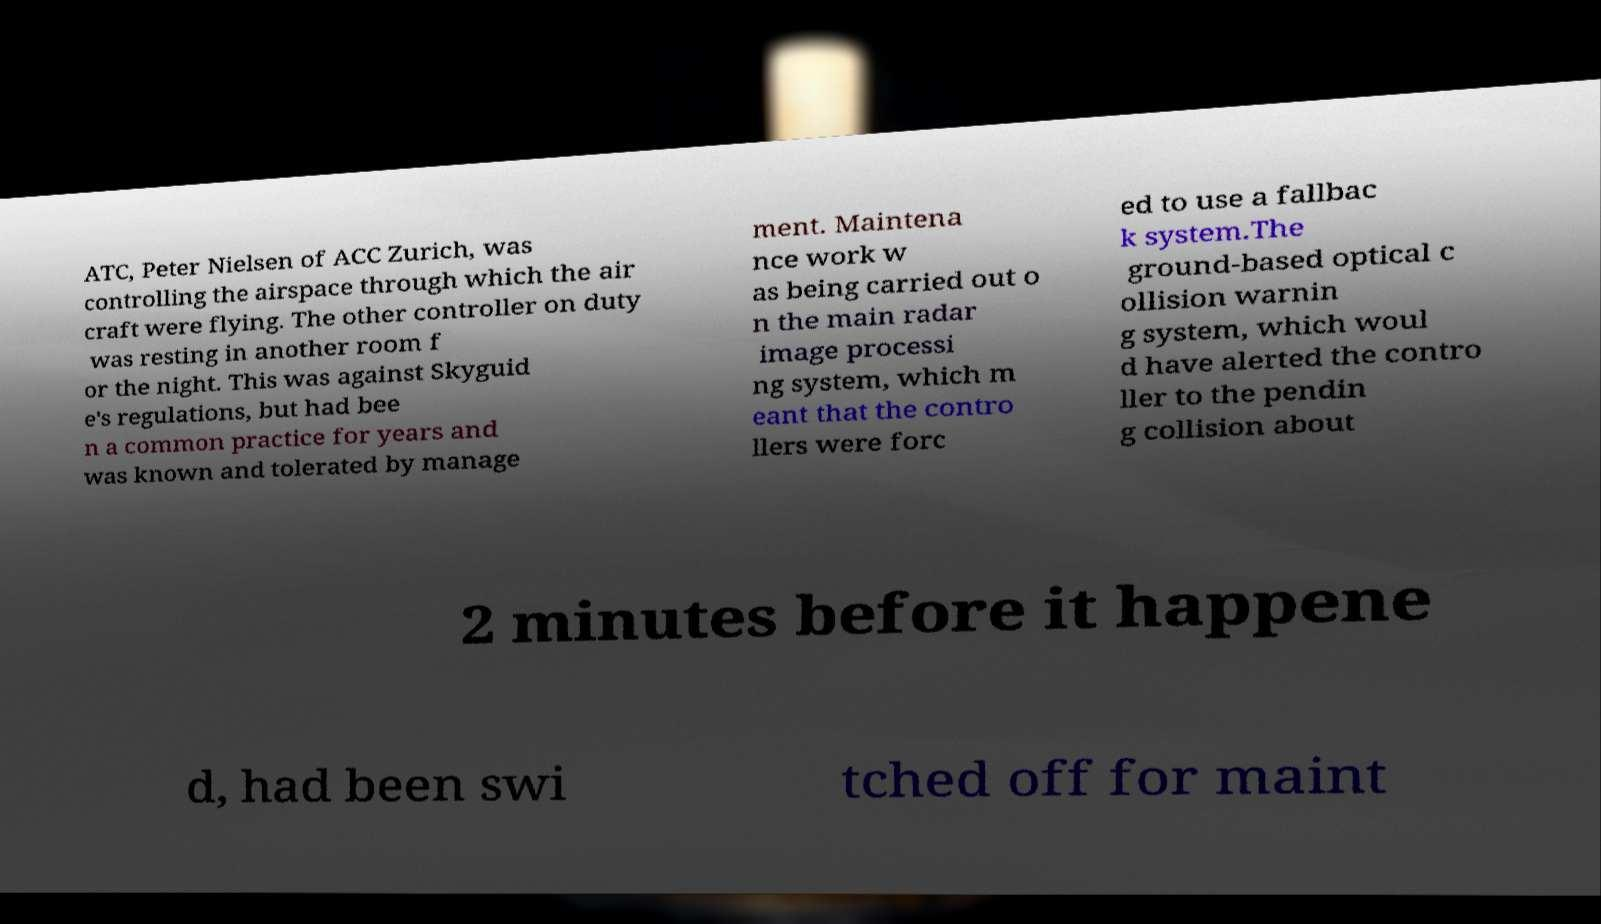I need the written content from this picture converted into text. Can you do that? ATC, Peter Nielsen of ACC Zurich, was controlling the airspace through which the air craft were flying. The other controller on duty was resting in another room f or the night. This was against Skyguid e's regulations, but had bee n a common practice for years and was known and tolerated by manage ment. Maintena nce work w as being carried out o n the main radar image processi ng system, which m eant that the contro llers were forc ed to use a fallbac k system.The ground-based optical c ollision warnin g system, which woul d have alerted the contro ller to the pendin g collision about 2 minutes before it happene d, had been swi tched off for maint 